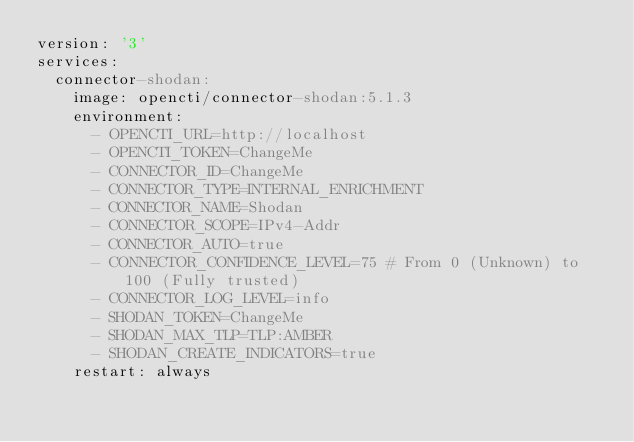Convert code to text. <code><loc_0><loc_0><loc_500><loc_500><_YAML_>version: '3'
services:
  connector-shodan:
    image: opencti/connector-shodan:5.1.3
    environment:
      - OPENCTI_URL=http://localhost
      - OPENCTI_TOKEN=ChangeMe
      - CONNECTOR_ID=ChangeMe
      - CONNECTOR_TYPE=INTERNAL_ENRICHMENT
      - CONNECTOR_NAME=Shodan
      - CONNECTOR_SCOPE=IPv4-Addr
      - CONNECTOR_AUTO=true
      - CONNECTOR_CONFIDENCE_LEVEL=75 # From 0 (Unknown) to 100 (Fully trusted)
      - CONNECTOR_LOG_LEVEL=info
      - SHODAN_TOKEN=ChangeMe
      - SHODAN_MAX_TLP=TLP:AMBER
      - SHODAN_CREATE_INDICATORS=true
    restart: always
</code> 